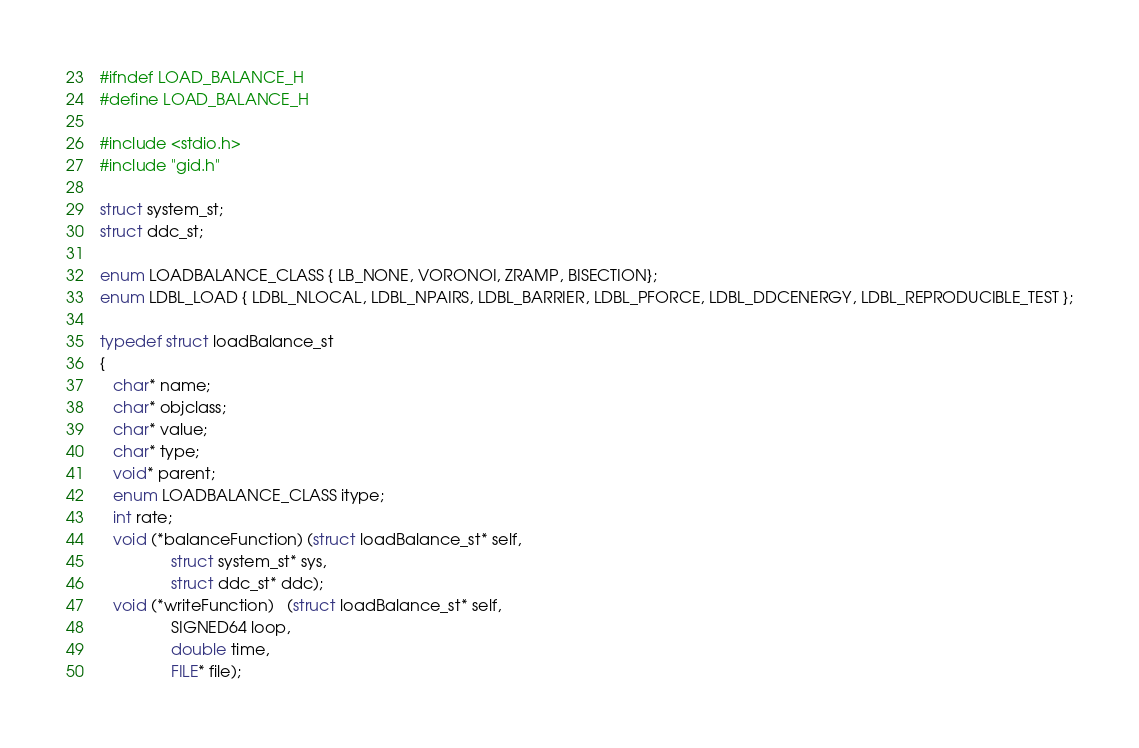Convert code to text. <code><loc_0><loc_0><loc_500><loc_500><_C_>#ifndef LOAD_BALANCE_H
#define LOAD_BALANCE_H

#include <stdio.h>
#include "gid.h"

struct system_st;
struct ddc_st;

enum LOADBALANCE_CLASS { LB_NONE, VORONOI, ZRAMP, BISECTION}; 
enum LDBL_LOAD { LDBL_NLOCAL, LDBL_NPAIRS, LDBL_BARRIER, LDBL_PFORCE, LDBL_DDCENERGY, LDBL_REPRODUCIBLE_TEST };

typedef struct loadBalance_st
{
   char* name;
   char* objclass;
   char* value;
   char* type;
   void* parent; 
   enum LOADBALANCE_CLASS itype; 
   int rate;
   void (*balanceFunction) (struct loadBalance_st* self,
			    struct system_st* sys,
			    struct ddc_st* ddc);
   void (*writeFunction)   (struct loadBalance_st* self,
			    SIGNED64 loop,
			    double time,
			    FILE* file);</code> 